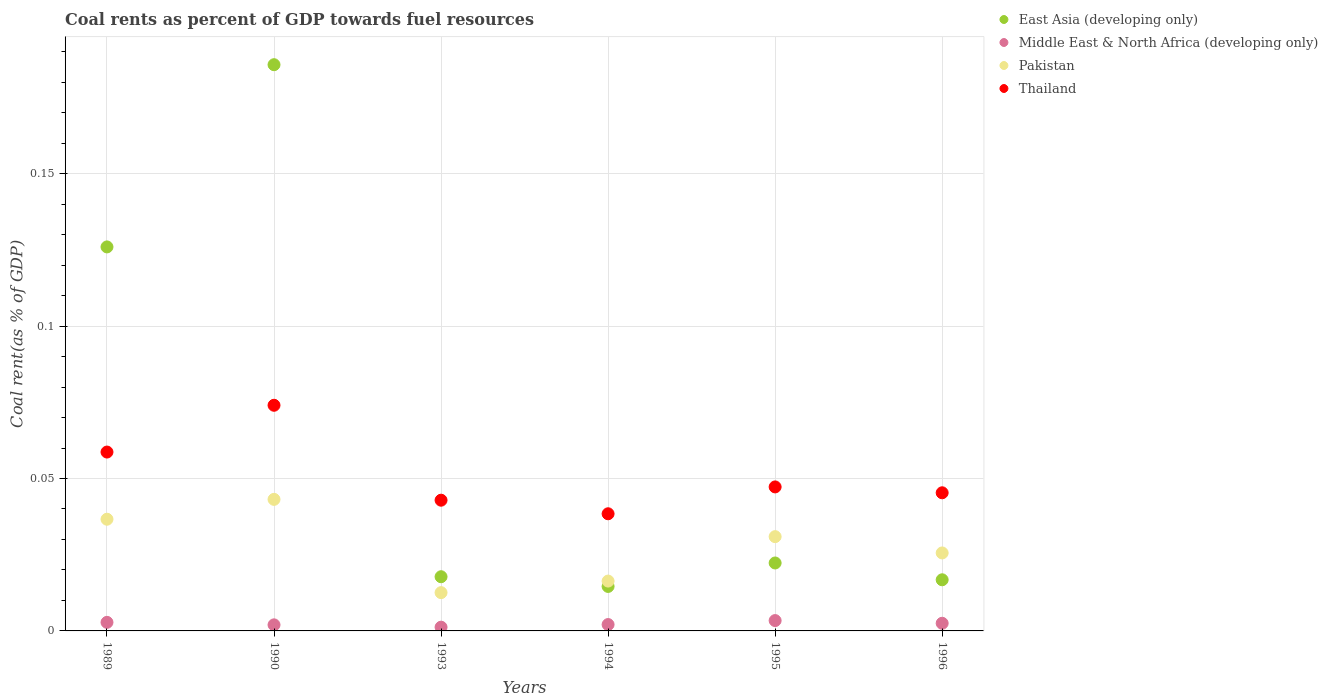Is the number of dotlines equal to the number of legend labels?
Ensure brevity in your answer.  Yes. What is the coal rent in Middle East & North Africa (developing only) in 1989?
Your response must be concise. 0. Across all years, what is the maximum coal rent in Thailand?
Ensure brevity in your answer.  0.07. Across all years, what is the minimum coal rent in Thailand?
Make the answer very short. 0.04. In which year was the coal rent in East Asia (developing only) maximum?
Offer a terse response. 1990. In which year was the coal rent in Middle East & North Africa (developing only) minimum?
Provide a succinct answer. 1993. What is the total coal rent in Pakistan in the graph?
Provide a succinct answer. 0.17. What is the difference between the coal rent in Pakistan in 1990 and that in 1994?
Ensure brevity in your answer.  0.03. What is the difference between the coal rent in East Asia (developing only) in 1993 and the coal rent in Thailand in 1996?
Provide a succinct answer. -0.03. What is the average coal rent in Thailand per year?
Your answer should be very brief. 0.05. In the year 1989, what is the difference between the coal rent in Pakistan and coal rent in Middle East & North Africa (developing only)?
Offer a terse response. 0.03. What is the ratio of the coal rent in Pakistan in 1990 to that in 1994?
Your answer should be very brief. 2.64. Is the difference between the coal rent in Pakistan in 1993 and 1994 greater than the difference between the coal rent in Middle East & North Africa (developing only) in 1993 and 1994?
Offer a very short reply. No. What is the difference between the highest and the second highest coal rent in Thailand?
Provide a succinct answer. 0.02. What is the difference between the highest and the lowest coal rent in Middle East & North Africa (developing only)?
Make the answer very short. 0. Is it the case that in every year, the sum of the coal rent in Thailand and coal rent in East Asia (developing only)  is greater than the sum of coal rent in Pakistan and coal rent in Middle East & North Africa (developing only)?
Ensure brevity in your answer.  Yes. Does the coal rent in Thailand monotonically increase over the years?
Provide a short and direct response. No. Is the coal rent in Thailand strictly greater than the coal rent in Middle East & North Africa (developing only) over the years?
Offer a very short reply. Yes. Is the coal rent in East Asia (developing only) strictly less than the coal rent in Thailand over the years?
Ensure brevity in your answer.  No. How many dotlines are there?
Provide a succinct answer. 4. Does the graph contain any zero values?
Your answer should be very brief. No. Does the graph contain grids?
Offer a terse response. Yes. Where does the legend appear in the graph?
Ensure brevity in your answer.  Top right. How many legend labels are there?
Keep it short and to the point. 4. What is the title of the graph?
Provide a succinct answer. Coal rents as percent of GDP towards fuel resources. What is the label or title of the Y-axis?
Offer a terse response. Coal rent(as % of GDP). What is the Coal rent(as % of GDP) of East Asia (developing only) in 1989?
Ensure brevity in your answer.  0.13. What is the Coal rent(as % of GDP) in Middle East & North Africa (developing only) in 1989?
Provide a short and direct response. 0. What is the Coal rent(as % of GDP) in Pakistan in 1989?
Give a very brief answer. 0.04. What is the Coal rent(as % of GDP) in Thailand in 1989?
Your answer should be compact. 0.06. What is the Coal rent(as % of GDP) in East Asia (developing only) in 1990?
Your response must be concise. 0.19. What is the Coal rent(as % of GDP) of Middle East & North Africa (developing only) in 1990?
Provide a short and direct response. 0. What is the Coal rent(as % of GDP) in Pakistan in 1990?
Give a very brief answer. 0.04. What is the Coal rent(as % of GDP) in Thailand in 1990?
Keep it short and to the point. 0.07. What is the Coal rent(as % of GDP) of East Asia (developing only) in 1993?
Offer a terse response. 0.02. What is the Coal rent(as % of GDP) in Middle East & North Africa (developing only) in 1993?
Make the answer very short. 0. What is the Coal rent(as % of GDP) in Pakistan in 1993?
Make the answer very short. 0.01. What is the Coal rent(as % of GDP) of Thailand in 1993?
Make the answer very short. 0.04. What is the Coal rent(as % of GDP) in East Asia (developing only) in 1994?
Keep it short and to the point. 0.01. What is the Coal rent(as % of GDP) in Middle East & North Africa (developing only) in 1994?
Ensure brevity in your answer.  0. What is the Coal rent(as % of GDP) of Pakistan in 1994?
Ensure brevity in your answer.  0.02. What is the Coal rent(as % of GDP) of Thailand in 1994?
Ensure brevity in your answer.  0.04. What is the Coal rent(as % of GDP) in East Asia (developing only) in 1995?
Give a very brief answer. 0.02. What is the Coal rent(as % of GDP) of Middle East & North Africa (developing only) in 1995?
Your answer should be very brief. 0. What is the Coal rent(as % of GDP) in Pakistan in 1995?
Provide a succinct answer. 0.03. What is the Coal rent(as % of GDP) of Thailand in 1995?
Keep it short and to the point. 0.05. What is the Coal rent(as % of GDP) of East Asia (developing only) in 1996?
Offer a very short reply. 0.02. What is the Coal rent(as % of GDP) in Middle East & North Africa (developing only) in 1996?
Your response must be concise. 0. What is the Coal rent(as % of GDP) of Pakistan in 1996?
Your response must be concise. 0.03. What is the Coal rent(as % of GDP) in Thailand in 1996?
Your answer should be very brief. 0.05. Across all years, what is the maximum Coal rent(as % of GDP) in East Asia (developing only)?
Give a very brief answer. 0.19. Across all years, what is the maximum Coal rent(as % of GDP) in Middle East & North Africa (developing only)?
Provide a short and direct response. 0. Across all years, what is the maximum Coal rent(as % of GDP) in Pakistan?
Give a very brief answer. 0.04. Across all years, what is the maximum Coal rent(as % of GDP) of Thailand?
Your answer should be very brief. 0.07. Across all years, what is the minimum Coal rent(as % of GDP) of East Asia (developing only)?
Keep it short and to the point. 0.01. Across all years, what is the minimum Coal rent(as % of GDP) in Middle East & North Africa (developing only)?
Your answer should be very brief. 0. Across all years, what is the minimum Coal rent(as % of GDP) in Pakistan?
Your answer should be compact. 0.01. Across all years, what is the minimum Coal rent(as % of GDP) of Thailand?
Your response must be concise. 0.04. What is the total Coal rent(as % of GDP) of East Asia (developing only) in the graph?
Provide a short and direct response. 0.38. What is the total Coal rent(as % of GDP) in Middle East & North Africa (developing only) in the graph?
Your response must be concise. 0.01. What is the total Coal rent(as % of GDP) of Pakistan in the graph?
Offer a very short reply. 0.17. What is the total Coal rent(as % of GDP) in Thailand in the graph?
Give a very brief answer. 0.31. What is the difference between the Coal rent(as % of GDP) of East Asia (developing only) in 1989 and that in 1990?
Offer a very short reply. -0.06. What is the difference between the Coal rent(as % of GDP) of Middle East & North Africa (developing only) in 1989 and that in 1990?
Offer a terse response. 0. What is the difference between the Coal rent(as % of GDP) of Pakistan in 1989 and that in 1990?
Provide a succinct answer. -0.01. What is the difference between the Coal rent(as % of GDP) in Thailand in 1989 and that in 1990?
Your answer should be very brief. -0.02. What is the difference between the Coal rent(as % of GDP) in East Asia (developing only) in 1989 and that in 1993?
Give a very brief answer. 0.11. What is the difference between the Coal rent(as % of GDP) of Middle East & North Africa (developing only) in 1989 and that in 1993?
Your answer should be compact. 0. What is the difference between the Coal rent(as % of GDP) of Pakistan in 1989 and that in 1993?
Provide a succinct answer. 0.02. What is the difference between the Coal rent(as % of GDP) in Thailand in 1989 and that in 1993?
Ensure brevity in your answer.  0.02. What is the difference between the Coal rent(as % of GDP) in East Asia (developing only) in 1989 and that in 1994?
Offer a terse response. 0.11. What is the difference between the Coal rent(as % of GDP) in Middle East & North Africa (developing only) in 1989 and that in 1994?
Make the answer very short. 0. What is the difference between the Coal rent(as % of GDP) in Pakistan in 1989 and that in 1994?
Keep it short and to the point. 0.02. What is the difference between the Coal rent(as % of GDP) of Thailand in 1989 and that in 1994?
Offer a very short reply. 0.02. What is the difference between the Coal rent(as % of GDP) of East Asia (developing only) in 1989 and that in 1995?
Keep it short and to the point. 0.1. What is the difference between the Coal rent(as % of GDP) of Middle East & North Africa (developing only) in 1989 and that in 1995?
Your response must be concise. -0. What is the difference between the Coal rent(as % of GDP) in Pakistan in 1989 and that in 1995?
Your answer should be compact. 0.01. What is the difference between the Coal rent(as % of GDP) of Thailand in 1989 and that in 1995?
Offer a terse response. 0.01. What is the difference between the Coal rent(as % of GDP) in East Asia (developing only) in 1989 and that in 1996?
Offer a very short reply. 0.11. What is the difference between the Coal rent(as % of GDP) in Middle East & North Africa (developing only) in 1989 and that in 1996?
Ensure brevity in your answer.  0. What is the difference between the Coal rent(as % of GDP) of Pakistan in 1989 and that in 1996?
Give a very brief answer. 0.01. What is the difference between the Coal rent(as % of GDP) in Thailand in 1989 and that in 1996?
Make the answer very short. 0.01. What is the difference between the Coal rent(as % of GDP) in East Asia (developing only) in 1990 and that in 1993?
Provide a succinct answer. 0.17. What is the difference between the Coal rent(as % of GDP) of Middle East & North Africa (developing only) in 1990 and that in 1993?
Give a very brief answer. 0. What is the difference between the Coal rent(as % of GDP) in Pakistan in 1990 and that in 1993?
Your response must be concise. 0.03. What is the difference between the Coal rent(as % of GDP) in Thailand in 1990 and that in 1993?
Make the answer very short. 0.03. What is the difference between the Coal rent(as % of GDP) of East Asia (developing only) in 1990 and that in 1994?
Provide a succinct answer. 0.17. What is the difference between the Coal rent(as % of GDP) of Middle East & North Africa (developing only) in 1990 and that in 1994?
Offer a very short reply. -0. What is the difference between the Coal rent(as % of GDP) of Pakistan in 1990 and that in 1994?
Provide a short and direct response. 0.03. What is the difference between the Coal rent(as % of GDP) of Thailand in 1990 and that in 1994?
Your response must be concise. 0.04. What is the difference between the Coal rent(as % of GDP) of East Asia (developing only) in 1990 and that in 1995?
Your answer should be very brief. 0.16. What is the difference between the Coal rent(as % of GDP) of Middle East & North Africa (developing only) in 1990 and that in 1995?
Keep it short and to the point. -0. What is the difference between the Coal rent(as % of GDP) of Pakistan in 1990 and that in 1995?
Offer a terse response. 0.01. What is the difference between the Coal rent(as % of GDP) in Thailand in 1990 and that in 1995?
Keep it short and to the point. 0.03. What is the difference between the Coal rent(as % of GDP) of East Asia (developing only) in 1990 and that in 1996?
Ensure brevity in your answer.  0.17. What is the difference between the Coal rent(as % of GDP) in Middle East & North Africa (developing only) in 1990 and that in 1996?
Ensure brevity in your answer.  -0. What is the difference between the Coal rent(as % of GDP) in Pakistan in 1990 and that in 1996?
Provide a short and direct response. 0.02. What is the difference between the Coal rent(as % of GDP) of Thailand in 1990 and that in 1996?
Your answer should be very brief. 0.03. What is the difference between the Coal rent(as % of GDP) of East Asia (developing only) in 1993 and that in 1994?
Provide a succinct answer. 0. What is the difference between the Coal rent(as % of GDP) of Middle East & North Africa (developing only) in 1993 and that in 1994?
Your response must be concise. -0. What is the difference between the Coal rent(as % of GDP) of Pakistan in 1993 and that in 1994?
Give a very brief answer. -0. What is the difference between the Coal rent(as % of GDP) of Thailand in 1993 and that in 1994?
Give a very brief answer. 0. What is the difference between the Coal rent(as % of GDP) in East Asia (developing only) in 1993 and that in 1995?
Your answer should be compact. -0. What is the difference between the Coal rent(as % of GDP) of Middle East & North Africa (developing only) in 1993 and that in 1995?
Provide a succinct answer. -0. What is the difference between the Coal rent(as % of GDP) in Pakistan in 1993 and that in 1995?
Provide a short and direct response. -0.02. What is the difference between the Coal rent(as % of GDP) of Thailand in 1993 and that in 1995?
Make the answer very short. -0. What is the difference between the Coal rent(as % of GDP) in East Asia (developing only) in 1993 and that in 1996?
Your answer should be very brief. 0. What is the difference between the Coal rent(as % of GDP) of Middle East & North Africa (developing only) in 1993 and that in 1996?
Offer a very short reply. -0. What is the difference between the Coal rent(as % of GDP) in Pakistan in 1993 and that in 1996?
Ensure brevity in your answer.  -0.01. What is the difference between the Coal rent(as % of GDP) in Thailand in 1993 and that in 1996?
Provide a succinct answer. -0. What is the difference between the Coal rent(as % of GDP) of East Asia (developing only) in 1994 and that in 1995?
Make the answer very short. -0.01. What is the difference between the Coal rent(as % of GDP) of Middle East & North Africa (developing only) in 1994 and that in 1995?
Provide a short and direct response. -0. What is the difference between the Coal rent(as % of GDP) of Pakistan in 1994 and that in 1995?
Give a very brief answer. -0.01. What is the difference between the Coal rent(as % of GDP) of Thailand in 1994 and that in 1995?
Provide a succinct answer. -0.01. What is the difference between the Coal rent(as % of GDP) of East Asia (developing only) in 1994 and that in 1996?
Keep it short and to the point. -0. What is the difference between the Coal rent(as % of GDP) in Middle East & North Africa (developing only) in 1994 and that in 1996?
Provide a succinct answer. -0. What is the difference between the Coal rent(as % of GDP) in Pakistan in 1994 and that in 1996?
Give a very brief answer. -0.01. What is the difference between the Coal rent(as % of GDP) in Thailand in 1994 and that in 1996?
Make the answer very short. -0.01. What is the difference between the Coal rent(as % of GDP) of East Asia (developing only) in 1995 and that in 1996?
Your answer should be very brief. 0.01. What is the difference between the Coal rent(as % of GDP) in Middle East & North Africa (developing only) in 1995 and that in 1996?
Give a very brief answer. 0. What is the difference between the Coal rent(as % of GDP) in Pakistan in 1995 and that in 1996?
Provide a succinct answer. 0.01. What is the difference between the Coal rent(as % of GDP) of Thailand in 1995 and that in 1996?
Provide a short and direct response. 0. What is the difference between the Coal rent(as % of GDP) of East Asia (developing only) in 1989 and the Coal rent(as % of GDP) of Middle East & North Africa (developing only) in 1990?
Ensure brevity in your answer.  0.12. What is the difference between the Coal rent(as % of GDP) of East Asia (developing only) in 1989 and the Coal rent(as % of GDP) of Pakistan in 1990?
Your answer should be very brief. 0.08. What is the difference between the Coal rent(as % of GDP) in East Asia (developing only) in 1989 and the Coal rent(as % of GDP) in Thailand in 1990?
Your answer should be compact. 0.05. What is the difference between the Coal rent(as % of GDP) of Middle East & North Africa (developing only) in 1989 and the Coal rent(as % of GDP) of Pakistan in 1990?
Your response must be concise. -0.04. What is the difference between the Coal rent(as % of GDP) of Middle East & North Africa (developing only) in 1989 and the Coal rent(as % of GDP) of Thailand in 1990?
Keep it short and to the point. -0.07. What is the difference between the Coal rent(as % of GDP) in Pakistan in 1989 and the Coal rent(as % of GDP) in Thailand in 1990?
Provide a short and direct response. -0.04. What is the difference between the Coal rent(as % of GDP) in East Asia (developing only) in 1989 and the Coal rent(as % of GDP) in Middle East & North Africa (developing only) in 1993?
Your answer should be very brief. 0.12. What is the difference between the Coal rent(as % of GDP) in East Asia (developing only) in 1989 and the Coal rent(as % of GDP) in Pakistan in 1993?
Offer a very short reply. 0.11. What is the difference between the Coal rent(as % of GDP) of East Asia (developing only) in 1989 and the Coal rent(as % of GDP) of Thailand in 1993?
Give a very brief answer. 0.08. What is the difference between the Coal rent(as % of GDP) of Middle East & North Africa (developing only) in 1989 and the Coal rent(as % of GDP) of Pakistan in 1993?
Your answer should be compact. -0.01. What is the difference between the Coal rent(as % of GDP) in Middle East & North Africa (developing only) in 1989 and the Coal rent(as % of GDP) in Thailand in 1993?
Offer a terse response. -0.04. What is the difference between the Coal rent(as % of GDP) of Pakistan in 1989 and the Coal rent(as % of GDP) of Thailand in 1993?
Keep it short and to the point. -0.01. What is the difference between the Coal rent(as % of GDP) in East Asia (developing only) in 1989 and the Coal rent(as % of GDP) in Middle East & North Africa (developing only) in 1994?
Offer a terse response. 0.12. What is the difference between the Coal rent(as % of GDP) in East Asia (developing only) in 1989 and the Coal rent(as % of GDP) in Pakistan in 1994?
Provide a succinct answer. 0.11. What is the difference between the Coal rent(as % of GDP) in East Asia (developing only) in 1989 and the Coal rent(as % of GDP) in Thailand in 1994?
Keep it short and to the point. 0.09. What is the difference between the Coal rent(as % of GDP) in Middle East & North Africa (developing only) in 1989 and the Coal rent(as % of GDP) in Pakistan in 1994?
Provide a short and direct response. -0.01. What is the difference between the Coal rent(as % of GDP) in Middle East & North Africa (developing only) in 1989 and the Coal rent(as % of GDP) in Thailand in 1994?
Offer a terse response. -0.04. What is the difference between the Coal rent(as % of GDP) of Pakistan in 1989 and the Coal rent(as % of GDP) of Thailand in 1994?
Keep it short and to the point. -0. What is the difference between the Coal rent(as % of GDP) in East Asia (developing only) in 1989 and the Coal rent(as % of GDP) in Middle East & North Africa (developing only) in 1995?
Your answer should be very brief. 0.12. What is the difference between the Coal rent(as % of GDP) of East Asia (developing only) in 1989 and the Coal rent(as % of GDP) of Pakistan in 1995?
Make the answer very short. 0.1. What is the difference between the Coal rent(as % of GDP) of East Asia (developing only) in 1989 and the Coal rent(as % of GDP) of Thailand in 1995?
Provide a succinct answer. 0.08. What is the difference between the Coal rent(as % of GDP) of Middle East & North Africa (developing only) in 1989 and the Coal rent(as % of GDP) of Pakistan in 1995?
Provide a short and direct response. -0.03. What is the difference between the Coal rent(as % of GDP) in Middle East & North Africa (developing only) in 1989 and the Coal rent(as % of GDP) in Thailand in 1995?
Offer a very short reply. -0.04. What is the difference between the Coal rent(as % of GDP) in Pakistan in 1989 and the Coal rent(as % of GDP) in Thailand in 1995?
Provide a short and direct response. -0.01. What is the difference between the Coal rent(as % of GDP) of East Asia (developing only) in 1989 and the Coal rent(as % of GDP) of Middle East & North Africa (developing only) in 1996?
Provide a succinct answer. 0.12. What is the difference between the Coal rent(as % of GDP) in East Asia (developing only) in 1989 and the Coal rent(as % of GDP) in Pakistan in 1996?
Offer a terse response. 0.1. What is the difference between the Coal rent(as % of GDP) in East Asia (developing only) in 1989 and the Coal rent(as % of GDP) in Thailand in 1996?
Your response must be concise. 0.08. What is the difference between the Coal rent(as % of GDP) in Middle East & North Africa (developing only) in 1989 and the Coal rent(as % of GDP) in Pakistan in 1996?
Your response must be concise. -0.02. What is the difference between the Coal rent(as % of GDP) in Middle East & North Africa (developing only) in 1989 and the Coal rent(as % of GDP) in Thailand in 1996?
Your answer should be compact. -0.04. What is the difference between the Coal rent(as % of GDP) in Pakistan in 1989 and the Coal rent(as % of GDP) in Thailand in 1996?
Your answer should be compact. -0.01. What is the difference between the Coal rent(as % of GDP) in East Asia (developing only) in 1990 and the Coal rent(as % of GDP) in Middle East & North Africa (developing only) in 1993?
Offer a very short reply. 0.18. What is the difference between the Coal rent(as % of GDP) of East Asia (developing only) in 1990 and the Coal rent(as % of GDP) of Pakistan in 1993?
Offer a terse response. 0.17. What is the difference between the Coal rent(as % of GDP) of East Asia (developing only) in 1990 and the Coal rent(as % of GDP) of Thailand in 1993?
Make the answer very short. 0.14. What is the difference between the Coal rent(as % of GDP) in Middle East & North Africa (developing only) in 1990 and the Coal rent(as % of GDP) in Pakistan in 1993?
Give a very brief answer. -0.01. What is the difference between the Coal rent(as % of GDP) of Middle East & North Africa (developing only) in 1990 and the Coal rent(as % of GDP) of Thailand in 1993?
Give a very brief answer. -0.04. What is the difference between the Coal rent(as % of GDP) in East Asia (developing only) in 1990 and the Coal rent(as % of GDP) in Middle East & North Africa (developing only) in 1994?
Keep it short and to the point. 0.18. What is the difference between the Coal rent(as % of GDP) of East Asia (developing only) in 1990 and the Coal rent(as % of GDP) of Pakistan in 1994?
Give a very brief answer. 0.17. What is the difference between the Coal rent(as % of GDP) of East Asia (developing only) in 1990 and the Coal rent(as % of GDP) of Thailand in 1994?
Your answer should be compact. 0.15. What is the difference between the Coal rent(as % of GDP) of Middle East & North Africa (developing only) in 1990 and the Coal rent(as % of GDP) of Pakistan in 1994?
Offer a very short reply. -0.01. What is the difference between the Coal rent(as % of GDP) in Middle East & North Africa (developing only) in 1990 and the Coal rent(as % of GDP) in Thailand in 1994?
Make the answer very short. -0.04. What is the difference between the Coal rent(as % of GDP) of Pakistan in 1990 and the Coal rent(as % of GDP) of Thailand in 1994?
Your answer should be compact. 0. What is the difference between the Coal rent(as % of GDP) in East Asia (developing only) in 1990 and the Coal rent(as % of GDP) in Middle East & North Africa (developing only) in 1995?
Provide a short and direct response. 0.18. What is the difference between the Coal rent(as % of GDP) in East Asia (developing only) in 1990 and the Coal rent(as % of GDP) in Pakistan in 1995?
Provide a succinct answer. 0.15. What is the difference between the Coal rent(as % of GDP) of East Asia (developing only) in 1990 and the Coal rent(as % of GDP) of Thailand in 1995?
Provide a succinct answer. 0.14. What is the difference between the Coal rent(as % of GDP) of Middle East & North Africa (developing only) in 1990 and the Coal rent(as % of GDP) of Pakistan in 1995?
Provide a succinct answer. -0.03. What is the difference between the Coal rent(as % of GDP) of Middle East & North Africa (developing only) in 1990 and the Coal rent(as % of GDP) of Thailand in 1995?
Keep it short and to the point. -0.05. What is the difference between the Coal rent(as % of GDP) in Pakistan in 1990 and the Coal rent(as % of GDP) in Thailand in 1995?
Your response must be concise. -0. What is the difference between the Coal rent(as % of GDP) in East Asia (developing only) in 1990 and the Coal rent(as % of GDP) in Middle East & North Africa (developing only) in 1996?
Your response must be concise. 0.18. What is the difference between the Coal rent(as % of GDP) in East Asia (developing only) in 1990 and the Coal rent(as % of GDP) in Pakistan in 1996?
Your answer should be compact. 0.16. What is the difference between the Coal rent(as % of GDP) in East Asia (developing only) in 1990 and the Coal rent(as % of GDP) in Thailand in 1996?
Offer a terse response. 0.14. What is the difference between the Coal rent(as % of GDP) in Middle East & North Africa (developing only) in 1990 and the Coal rent(as % of GDP) in Pakistan in 1996?
Your answer should be very brief. -0.02. What is the difference between the Coal rent(as % of GDP) of Middle East & North Africa (developing only) in 1990 and the Coal rent(as % of GDP) of Thailand in 1996?
Offer a very short reply. -0.04. What is the difference between the Coal rent(as % of GDP) of Pakistan in 1990 and the Coal rent(as % of GDP) of Thailand in 1996?
Provide a succinct answer. -0. What is the difference between the Coal rent(as % of GDP) in East Asia (developing only) in 1993 and the Coal rent(as % of GDP) in Middle East & North Africa (developing only) in 1994?
Provide a succinct answer. 0.02. What is the difference between the Coal rent(as % of GDP) of East Asia (developing only) in 1993 and the Coal rent(as % of GDP) of Pakistan in 1994?
Your response must be concise. 0. What is the difference between the Coal rent(as % of GDP) in East Asia (developing only) in 1993 and the Coal rent(as % of GDP) in Thailand in 1994?
Give a very brief answer. -0.02. What is the difference between the Coal rent(as % of GDP) of Middle East & North Africa (developing only) in 1993 and the Coal rent(as % of GDP) of Pakistan in 1994?
Keep it short and to the point. -0.02. What is the difference between the Coal rent(as % of GDP) in Middle East & North Africa (developing only) in 1993 and the Coal rent(as % of GDP) in Thailand in 1994?
Your response must be concise. -0.04. What is the difference between the Coal rent(as % of GDP) of Pakistan in 1993 and the Coal rent(as % of GDP) of Thailand in 1994?
Provide a succinct answer. -0.03. What is the difference between the Coal rent(as % of GDP) in East Asia (developing only) in 1993 and the Coal rent(as % of GDP) in Middle East & North Africa (developing only) in 1995?
Provide a succinct answer. 0.01. What is the difference between the Coal rent(as % of GDP) in East Asia (developing only) in 1993 and the Coal rent(as % of GDP) in Pakistan in 1995?
Provide a short and direct response. -0.01. What is the difference between the Coal rent(as % of GDP) in East Asia (developing only) in 1993 and the Coal rent(as % of GDP) in Thailand in 1995?
Keep it short and to the point. -0.03. What is the difference between the Coal rent(as % of GDP) of Middle East & North Africa (developing only) in 1993 and the Coal rent(as % of GDP) of Pakistan in 1995?
Your answer should be very brief. -0.03. What is the difference between the Coal rent(as % of GDP) of Middle East & North Africa (developing only) in 1993 and the Coal rent(as % of GDP) of Thailand in 1995?
Make the answer very short. -0.05. What is the difference between the Coal rent(as % of GDP) of Pakistan in 1993 and the Coal rent(as % of GDP) of Thailand in 1995?
Ensure brevity in your answer.  -0.03. What is the difference between the Coal rent(as % of GDP) of East Asia (developing only) in 1993 and the Coal rent(as % of GDP) of Middle East & North Africa (developing only) in 1996?
Offer a very short reply. 0.02. What is the difference between the Coal rent(as % of GDP) of East Asia (developing only) in 1993 and the Coal rent(as % of GDP) of Pakistan in 1996?
Offer a terse response. -0.01. What is the difference between the Coal rent(as % of GDP) in East Asia (developing only) in 1993 and the Coal rent(as % of GDP) in Thailand in 1996?
Your answer should be compact. -0.03. What is the difference between the Coal rent(as % of GDP) of Middle East & North Africa (developing only) in 1993 and the Coal rent(as % of GDP) of Pakistan in 1996?
Keep it short and to the point. -0.02. What is the difference between the Coal rent(as % of GDP) of Middle East & North Africa (developing only) in 1993 and the Coal rent(as % of GDP) of Thailand in 1996?
Keep it short and to the point. -0.04. What is the difference between the Coal rent(as % of GDP) in Pakistan in 1993 and the Coal rent(as % of GDP) in Thailand in 1996?
Your answer should be very brief. -0.03. What is the difference between the Coal rent(as % of GDP) in East Asia (developing only) in 1994 and the Coal rent(as % of GDP) in Middle East & North Africa (developing only) in 1995?
Provide a succinct answer. 0.01. What is the difference between the Coal rent(as % of GDP) in East Asia (developing only) in 1994 and the Coal rent(as % of GDP) in Pakistan in 1995?
Provide a short and direct response. -0.02. What is the difference between the Coal rent(as % of GDP) of East Asia (developing only) in 1994 and the Coal rent(as % of GDP) of Thailand in 1995?
Offer a terse response. -0.03. What is the difference between the Coal rent(as % of GDP) of Middle East & North Africa (developing only) in 1994 and the Coal rent(as % of GDP) of Pakistan in 1995?
Your answer should be very brief. -0.03. What is the difference between the Coal rent(as % of GDP) in Middle East & North Africa (developing only) in 1994 and the Coal rent(as % of GDP) in Thailand in 1995?
Your answer should be very brief. -0.05. What is the difference between the Coal rent(as % of GDP) of Pakistan in 1994 and the Coal rent(as % of GDP) of Thailand in 1995?
Offer a terse response. -0.03. What is the difference between the Coal rent(as % of GDP) of East Asia (developing only) in 1994 and the Coal rent(as % of GDP) of Middle East & North Africa (developing only) in 1996?
Your answer should be compact. 0.01. What is the difference between the Coal rent(as % of GDP) in East Asia (developing only) in 1994 and the Coal rent(as % of GDP) in Pakistan in 1996?
Your answer should be compact. -0.01. What is the difference between the Coal rent(as % of GDP) in East Asia (developing only) in 1994 and the Coal rent(as % of GDP) in Thailand in 1996?
Provide a succinct answer. -0.03. What is the difference between the Coal rent(as % of GDP) in Middle East & North Africa (developing only) in 1994 and the Coal rent(as % of GDP) in Pakistan in 1996?
Provide a succinct answer. -0.02. What is the difference between the Coal rent(as % of GDP) in Middle East & North Africa (developing only) in 1994 and the Coal rent(as % of GDP) in Thailand in 1996?
Keep it short and to the point. -0.04. What is the difference between the Coal rent(as % of GDP) of Pakistan in 1994 and the Coal rent(as % of GDP) of Thailand in 1996?
Provide a succinct answer. -0.03. What is the difference between the Coal rent(as % of GDP) of East Asia (developing only) in 1995 and the Coal rent(as % of GDP) of Middle East & North Africa (developing only) in 1996?
Ensure brevity in your answer.  0.02. What is the difference between the Coal rent(as % of GDP) of East Asia (developing only) in 1995 and the Coal rent(as % of GDP) of Pakistan in 1996?
Offer a very short reply. -0. What is the difference between the Coal rent(as % of GDP) in East Asia (developing only) in 1995 and the Coal rent(as % of GDP) in Thailand in 1996?
Ensure brevity in your answer.  -0.02. What is the difference between the Coal rent(as % of GDP) in Middle East & North Africa (developing only) in 1995 and the Coal rent(as % of GDP) in Pakistan in 1996?
Offer a very short reply. -0.02. What is the difference between the Coal rent(as % of GDP) of Middle East & North Africa (developing only) in 1995 and the Coal rent(as % of GDP) of Thailand in 1996?
Your response must be concise. -0.04. What is the difference between the Coal rent(as % of GDP) in Pakistan in 1995 and the Coal rent(as % of GDP) in Thailand in 1996?
Your response must be concise. -0.01. What is the average Coal rent(as % of GDP) of East Asia (developing only) per year?
Provide a succinct answer. 0.06. What is the average Coal rent(as % of GDP) of Middle East & North Africa (developing only) per year?
Your response must be concise. 0. What is the average Coal rent(as % of GDP) in Pakistan per year?
Offer a terse response. 0.03. What is the average Coal rent(as % of GDP) of Thailand per year?
Ensure brevity in your answer.  0.05. In the year 1989, what is the difference between the Coal rent(as % of GDP) in East Asia (developing only) and Coal rent(as % of GDP) in Middle East & North Africa (developing only)?
Your answer should be very brief. 0.12. In the year 1989, what is the difference between the Coal rent(as % of GDP) of East Asia (developing only) and Coal rent(as % of GDP) of Pakistan?
Your answer should be very brief. 0.09. In the year 1989, what is the difference between the Coal rent(as % of GDP) of East Asia (developing only) and Coal rent(as % of GDP) of Thailand?
Offer a very short reply. 0.07. In the year 1989, what is the difference between the Coal rent(as % of GDP) in Middle East & North Africa (developing only) and Coal rent(as % of GDP) in Pakistan?
Your answer should be compact. -0.03. In the year 1989, what is the difference between the Coal rent(as % of GDP) in Middle East & North Africa (developing only) and Coal rent(as % of GDP) in Thailand?
Provide a short and direct response. -0.06. In the year 1989, what is the difference between the Coal rent(as % of GDP) in Pakistan and Coal rent(as % of GDP) in Thailand?
Provide a succinct answer. -0.02. In the year 1990, what is the difference between the Coal rent(as % of GDP) of East Asia (developing only) and Coal rent(as % of GDP) of Middle East & North Africa (developing only)?
Your response must be concise. 0.18. In the year 1990, what is the difference between the Coal rent(as % of GDP) of East Asia (developing only) and Coal rent(as % of GDP) of Pakistan?
Give a very brief answer. 0.14. In the year 1990, what is the difference between the Coal rent(as % of GDP) of East Asia (developing only) and Coal rent(as % of GDP) of Thailand?
Your response must be concise. 0.11. In the year 1990, what is the difference between the Coal rent(as % of GDP) in Middle East & North Africa (developing only) and Coal rent(as % of GDP) in Pakistan?
Keep it short and to the point. -0.04. In the year 1990, what is the difference between the Coal rent(as % of GDP) of Middle East & North Africa (developing only) and Coal rent(as % of GDP) of Thailand?
Keep it short and to the point. -0.07. In the year 1990, what is the difference between the Coal rent(as % of GDP) of Pakistan and Coal rent(as % of GDP) of Thailand?
Give a very brief answer. -0.03. In the year 1993, what is the difference between the Coal rent(as % of GDP) in East Asia (developing only) and Coal rent(as % of GDP) in Middle East & North Africa (developing only)?
Your answer should be compact. 0.02. In the year 1993, what is the difference between the Coal rent(as % of GDP) in East Asia (developing only) and Coal rent(as % of GDP) in Pakistan?
Offer a very short reply. 0.01. In the year 1993, what is the difference between the Coal rent(as % of GDP) of East Asia (developing only) and Coal rent(as % of GDP) of Thailand?
Make the answer very short. -0.03. In the year 1993, what is the difference between the Coal rent(as % of GDP) of Middle East & North Africa (developing only) and Coal rent(as % of GDP) of Pakistan?
Give a very brief answer. -0.01. In the year 1993, what is the difference between the Coal rent(as % of GDP) in Middle East & North Africa (developing only) and Coal rent(as % of GDP) in Thailand?
Ensure brevity in your answer.  -0.04. In the year 1993, what is the difference between the Coal rent(as % of GDP) in Pakistan and Coal rent(as % of GDP) in Thailand?
Make the answer very short. -0.03. In the year 1994, what is the difference between the Coal rent(as % of GDP) of East Asia (developing only) and Coal rent(as % of GDP) of Middle East & North Africa (developing only)?
Offer a terse response. 0.01. In the year 1994, what is the difference between the Coal rent(as % of GDP) of East Asia (developing only) and Coal rent(as % of GDP) of Pakistan?
Ensure brevity in your answer.  -0. In the year 1994, what is the difference between the Coal rent(as % of GDP) in East Asia (developing only) and Coal rent(as % of GDP) in Thailand?
Keep it short and to the point. -0.02. In the year 1994, what is the difference between the Coal rent(as % of GDP) in Middle East & North Africa (developing only) and Coal rent(as % of GDP) in Pakistan?
Offer a very short reply. -0.01. In the year 1994, what is the difference between the Coal rent(as % of GDP) of Middle East & North Africa (developing only) and Coal rent(as % of GDP) of Thailand?
Provide a succinct answer. -0.04. In the year 1994, what is the difference between the Coal rent(as % of GDP) of Pakistan and Coal rent(as % of GDP) of Thailand?
Offer a very short reply. -0.02. In the year 1995, what is the difference between the Coal rent(as % of GDP) in East Asia (developing only) and Coal rent(as % of GDP) in Middle East & North Africa (developing only)?
Offer a very short reply. 0.02. In the year 1995, what is the difference between the Coal rent(as % of GDP) of East Asia (developing only) and Coal rent(as % of GDP) of Pakistan?
Keep it short and to the point. -0.01. In the year 1995, what is the difference between the Coal rent(as % of GDP) in East Asia (developing only) and Coal rent(as % of GDP) in Thailand?
Give a very brief answer. -0.03. In the year 1995, what is the difference between the Coal rent(as % of GDP) of Middle East & North Africa (developing only) and Coal rent(as % of GDP) of Pakistan?
Your answer should be very brief. -0.03. In the year 1995, what is the difference between the Coal rent(as % of GDP) in Middle East & North Africa (developing only) and Coal rent(as % of GDP) in Thailand?
Ensure brevity in your answer.  -0.04. In the year 1995, what is the difference between the Coal rent(as % of GDP) in Pakistan and Coal rent(as % of GDP) in Thailand?
Your answer should be very brief. -0.02. In the year 1996, what is the difference between the Coal rent(as % of GDP) of East Asia (developing only) and Coal rent(as % of GDP) of Middle East & North Africa (developing only)?
Keep it short and to the point. 0.01. In the year 1996, what is the difference between the Coal rent(as % of GDP) of East Asia (developing only) and Coal rent(as % of GDP) of Pakistan?
Your response must be concise. -0.01. In the year 1996, what is the difference between the Coal rent(as % of GDP) of East Asia (developing only) and Coal rent(as % of GDP) of Thailand?
Your response must be concise. -0.03. In the year 1996, what is the difference between the Coal rent(as % of GDP) of Middle East & North Africa (developing only) and Coal rent(as % of GDP) of Pakistan?
Keep it short and to the point. -0.02. In the year 1996, what is the difference between the Coal rent(as % of GDP) of Middle East & North Africa (developing only) and Coal rent(as % of GDP) of Thailand?
Provide a short and direct response. -0.04. In the year 1996, what is the difference between the Coal rent(as % of GDP) of Pakistan and Coal rent(as % of GDP) of Thailand?
Ensure brevity in your answer.  -0.02. What is the ratio of the Coal rent(as % of GDP) of East Asia (developing only) in 1989 to that in 1990?
Ensure brevity in your answer.  0.68. What is the ratio of the Coal rent(as % of GDP) of Middle East & North Africa (developing only) in 1989 to that in 1990?
Keep it short and to the point. 1.41. What is the ratio of the Coal rent(as % of GDP) in Pakistan in 1989 to that in 1990?
Your answer should be very brief. 0.85. What is the ratio of the Coal rent(as % of GDP) of Thailand in 1989 to that in 1990?
Your answer should be compact. 0.79. What is the ratio of the Coal rent(as % of GDP) of East Asia (developing only) in 1989 to that in 1993?
Provide a short and direct response. 7.09. What is the ratio of the Coal rent(as % of GDP) in Middle East & North Africa (developing only) in 1989 to that in 1993?
Keep it short and to the point. 2.29. What is the ratio of the Coal rent(as % of GDP) of Pakistan in 1989 to that in 1993?
Provide a short and direct response. 2.92. What is the ratio of the Coal rent(as % of GDP) of Thailand in 1989 to that in 1993?
Your answer should be very brief. 1.37. What is the ratio of the Coal rent(as % of GDP) in East Asia (developing only) in 1989 to that in 1994?
Your answer should be compact. 8.63. What is the ratio of the Coal rent(as % of GDP) in Middle East & North Africa (developing only) in 1989 to that in 1994?
Offer a terse response. 1.34. What is the ratio of the Coal rent(as % of GDP) of Pakistan in 1989 to that in 1994?
Your answer should be very brief. 2.24. What is the ratio of the Coal rent(as % of GDP) of Thailand in 1989 to that in 1994?
Ensure brevity in your answer.  1.53. What is the ratio of the Coal rent(as % of GDP) in East Asia (developing only) in 1989 to that in 1995?
Your answer should be very brief. 5.65. What is the ratio of the Coal rent(as % of GDP) in Middle East & North Africa (developing only) in 1989 to that in 1995?
Give a very brief answer. 0.83. What is the ratio of the Coal rent(as % of GDP) of Pakistan in 1989 to that in 1995?
Offer a very short reply. 1.18. What is the ratio of the Coal rent(as % of GDP) of Thailand in 1989 to that in 1995?
Your answer should be very brief. 1.24. What is the ratio of the Coal rent(as % of GDP) of East Asia (developing only) in 1989 to that in 1996?
Offer a terse response. 7.51. What is the ratio of the Coal rent(as % of GDP) of Middle East & North Africa (developing only) in 1989 to that in 1996?
Your answer should be very brief. 1.12. What is the ratio of the Coal rent(as % of GDP) of Pakistan in 1989 to that in 1996?
Make the answer very short. 1.43. What is the ratio of the Coal rent(as % of GDP) in Thailand in 1989 to that in 1996?
Ensure brevity in your answer.  1.29. What is the ratio of the Coal rent(as % of GDP) in East Asia (developing only) in 1990 to that in 1993?
Offer a very short reply. 10.45. What is the ratio of the Coal rent(as % of GDP) in Middle East & North Africa (developing only) in 1990 to that in 1993?
Your response must be concise. 1.62. What is the ratio of the Coal rent(as % of GDP) in Pakistan in 1990 to that in 1993?
Give a very brief answer. 3.44. What is the ratio of the Coal rent(as % of GDP) in Thailand in 1990 to that in 1993?
Keep it short and to the point. 1.73. What is the ratio of the Coal rent(as % of GDP) of East Asia (developing only) in 1990 to that in 1994?
Give a very brief answer. 12.73. What is the ratio of the Coal rent(as % of GDP) of Middle East & North Africa (developing only) in 1990 to that in 1994?
Provide a succinct answer. 0.95. What is the ratio of the Coal rent(as % of GDP) of Pakistan in 1990 to that in 1994?
Your answer should be very brief. 2.64. What is the ratio of the Coal rent(as % of GDP) in Thailand in 1990 to that in 1994?
Your answer should be very brief. 1.93. What is the ratio of the Coal rent(as % of GDP) in East Asia (developing only) in 1990 to that in 1995?
Offer a very short reply. 8.33. What is the ratio of the Coal rent(as % of GDP) of Middle East & North Africa (developing only) in 1990 to that in 1995?
Make the answer very short. 0.59. What is the ratio of the Coal rent(as % of GDP) in Pakistan in 1990 to that in 1995?
Provide a short and direct response. 1.4. What is the ratio of the Coal rent(as % of GDP) in Thailand in 1990 to that in 1995?
Ensure brevity in your answer.  1.57. What is the ratio of the Coal rent(as % of GDP) in East Asia (developing only) in 1990 to that in 1996?
Keep it short and to the point. 11.07. What is the ratio of the Coal rent(as % of GDP) of Middle East & North Africa (developing only) in 1990 to that in 1996?
Your response must be concise. 0.8. What is the ratio of the Coal rent(as % of GDP) in Pakistan in 1990 to that in 1996?
Keep it short and to the point. 1.69. What is the ratio of the Coal rent(as % of GDP) of Thailand in 1990 to that in 1996?
Make the answer very short. 1.63. What is the ratio of the Coal rent(as % of GDP) of East Asia (developing only) in 1993 to that in 1994?
Provide a succinct answer. 1.22. What is the ratio of the Coal rent(as % of GDP) of Middle East & North Africa (developing only) in 1993 to that in 1994?
Make the answer very short. 0.59. What is the ratio of the Coal rent(as % of GDP) of Pakistan in 1993 to that in 1994?
Provide a succinct answer. 0.77. What is the ratio of the Coal rent(as % of GDP) in Thailand in 1993 to that in 1994?
Provide a succinct answer. 1.12. What is the ratio of the Coal rent(as % of GDP) in East Asia (developing only) in 1993 to that in 1995?
Provide a succinct answer. 0.8. What is the ratio of the Coal rent(as % of GDP) of Middle East & North Africa (developing only) in 1993 to that in 1995?
Your answer should be very brief. 0.36. What is the ratio of the Coal rent(as % of GDP) in Pakistan in 1993 to that in 1995?
Your answer should be very brief. 0.41. What is the ratio of the Coal rent(as % of GDP) of Thailand in 1993 to that in 1995?
Offer a terse response. 0.91. What is the ratio of the Coal rent(as % of GDP) in East Asia (developing only) in 1993 to that in 1996?
Offer a terse response. 1.06. What is the ratio of the Coal rent(as % of GDP) of Middle East & North Africa (developing only) in 1993 to that in 1996?
Provide a succinct answer. 0.49. What is the ratio of the Coal rent(as % of GDP) in Pakistan in 1993 to that in 1996?
Make the answer very short. 0.49. What is the ratio of the Coal rent(as % of GDP) in Thailand in 1993 to that in 1996?
Provide a succinct answer. 0.95. What is the ratio of the Coal rent(as % of GDP) in East Asia (developing only) in 1994 to that in 1995?
Make the answer very short. 0.65. What is the ratio of the Coal rent(as % of GDP) in Middle East & North Africa (developing only) in 1994 to that in 1995?
Offer a very short reply. 0.62. What is the ratio of the Coal rent(as % of GDP) in Pakistan in 1994 to that in 1995?
Your answer should be compact. 0.53. What is the ratio of the Coal rent(as % of GDP) in Thailand in 1994 to that in 1995?
Keep it short and to the point. 0.81. What is the ratio of the Coal rent(as % of GDP) in East Asia (developing only) in 1994 to that in 1996?
Offer a terse response. 0.87. What is the ratio of the Coal rent(as % of GDP) of Middle East & North Africa (developing only) in 1994 to that in 1996?
Your answer should be very brief. 0.83. What is the ratio of the Coal rent(as % of GDP) of Pakistan in 1994 to that in 1996?
Your answer should be very brief. 0.64. What is the ratio of the Coal rent(as % of GDP) in Thailand in 1994 to that in 1996?
Your response must be concise. 0.85. What is the ratio of the Coal rent(as % of GDP) in East Asia (developing only) in 1995 to that in 1996?
Make the answer very short. 1.33. What is the ratio of the Coal rent(as % of GDP) in Middle East & North Africa (developing only) in 1995 to that in 1996?
Your response must be concise. 1.35. What is the ratio of the Coal rent(as % of GDP) of Pakistan in 1995 to that in 1996?
Your response must be concise. 1.21. What is the ratio of the Coal rent(as % of GDP) in Thailand in 1995 to that in 1996?
Keep it short and to the point. 1.04. What is the difference between the highest and the second highest Coal rent(as % of GDP) in East Asia (developing only)?
Your answer should be compact. 0.06. What is the difference between the highest and the second highest Coal rent(as % of GDP) of Middle East & North Africa (developing only)?
Offer a terse response. 0. What is the difference between the highest and the second highest Coal rent(as % of GDP) of Pakistan?
Make the answer very short. 0.01. What is the difference between the highest and the second highest Coal rent(as % of GDP) in Thailand?
Make the answer very short. 0.02. What is the difference between the highest and the lowest Coal rent(as % of GDP) in East Asia (developing only)?
Keep it short and to the point. 0.17. What is the difference between the highest and the lowest Coal rent(as % of GDP) in Middle East & North Africa (developing only)?
Your response must be concise. 0. What is the difference between the highest and the lowest Coal rent(as % of GDP) in Pakistan?
Your answer should be very brief. 0.03. What is the difference between the highest and the lowest Coal rent(as % of GDP) in Thailand?
Your answer should be very brief. 0.04. 